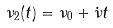<formula> <loc_0><loc_0><loc_500><loc_500>\nu _ { 2 } ( t ) = \nu _ { 0 } + { \dot { \nu } } t</formula> 